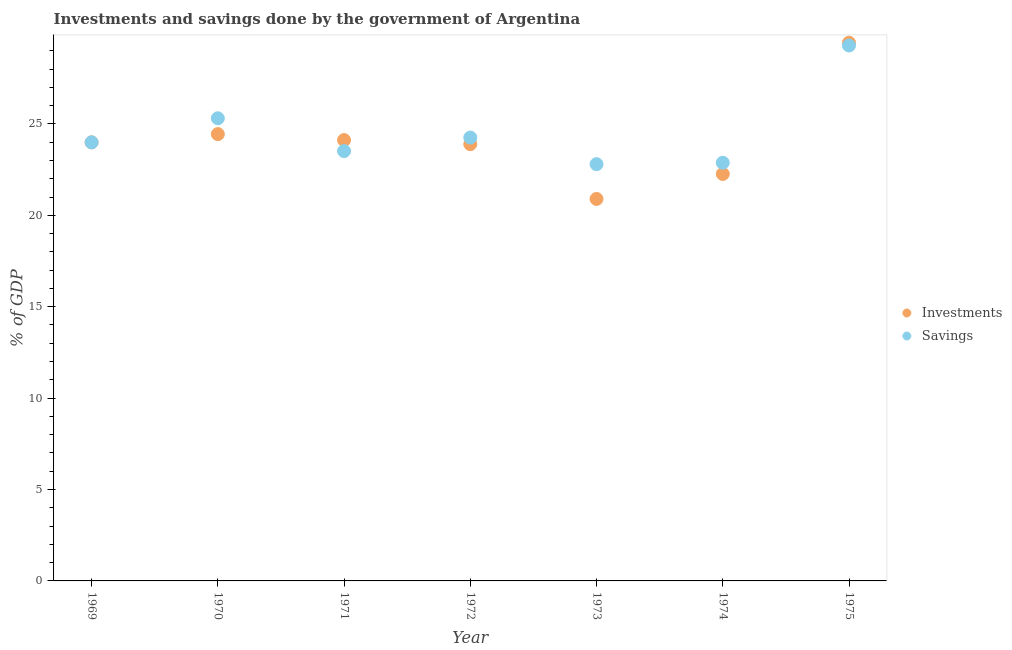What is the investments of government in 1975?
Your answer should be very brief. 29.44. Across all years, what is the maximum investments of government?
Make the answer very short. 29.44. Across all years, what is the minimum savings of government?
Your response must be concise. 22.8. In which year was the investments of government maximum?
Provide a short and direct response. 1975. In which year was the investments of government minimum?
Your answer should be very brief. 1973. What is the total investments of government in the graph?
Provide a succinct answer. 169.03. What is the difference between the savings of government in 1969 and that in 1972?
Keep it short and to the point. -0.26. What is the difference between the investments of government in 1969 and the savings of government in 1970?
Make the answer very short. -1.32. What is the average investments of government per year?
Your response must be concise. 24.15. In the year 1971, what is the difference between the investments of government and savings of government?
Your response must be concise. 0.6. In how many years, is the investments of government greater than 21 %?
Make the answer very short. 6. What is the ratio of the investments of government in 1974 to that in 1975?
Your answer should be very brief. 0.76. Is the investments of government in 1969 less than that in 1974?
Offer a very short reply. No. What is the difference between the highest and the second highest savings of government?
Offer a terse response. 3.98. What is the difference between the highest and the lowest savings of government?
Offer a terse response. 6.49. In how many years, is the investments of government greater than the average investments of government taken over all years?
Your answer should be very brief. 2. Is the sum of the savings of government in 1969 and 1975 greater than the maximum investments of government across all years?
Ensure brevity in your answer.  Yes. Is the savings of government strictly greater than the investments of government over the years?
Your response must be concise. No. How many dotlines are there?
Keep it short and to the point. 2. How many years are there in the graph?
Your answer should be compact. 7. What is the difference between two consecutive major ticks on the Y-axis?
Give a very brief answer. 5. Does the graph contain grids?
Keep it short and to the point. No. How are the legend labels stacked?
Provide a short and direct response. Vertical. What is the title of the graph?
Provide a succinct answer. Investments and savings done by the government of Argentina. Does "Largest city" appear as one of the legend labels in the graph?
Keep it short and to the point. No. What is the label or title of the X-axis?
Offer a very short reply. Year. What is the label or title of the Y-axis?
Provide a short and direct response. % of GDP. What is the % of GDP of Investments in 1969?
Make the answer very short. 23.99. What is the % of GDP in Savings in 1969?
Your answer should be compact. 23.99. What is the % of GDP of Investments in 1970?
Provide a succinct answer. 24.44. What is the % of GDP in Savings in 1970?
Keep it short and to the point. 25.31. What is the % of GDP in Investments in 1971?
Keep it short and to the point. 24.11. What is the % of GDP in Savings in 1971?
Keep it short and to the point. 23.51. What is the % of GDP of Investments in 1972?
Make the answer very short. 23.89. What is the % of GDP of Savings in 1972?
Offer a very short reply. 24.25. What is the % of GDP in Investments in 1973?
Offer a very short reply. 20.89. What is the % of GDP in Savings in 1973?
Give a very brief answer. 22.8. What is the % of GDP in Investments in 1974?
Offer a very short reply. 22.26. What is the % of GDP of Savings in 1974?
Your answer should be very brief. 22.87. What is the % of GDP of Investments in 1975?
Your answer should be very brief. 29.44. What is the % of GDP of Savings in 1975?
Provide a succinct answer. 29.29. Across all years, what is the maximum % of GDP in Investments?
Your answer should be very brief. 29.44. Across all years, what is the maximum % of GDP of Savings?
Offer a very short reply. 29.29. Across all years, what is the minimum % of GDP in Investments?
Provide a short and direct response. 20.89. Across all years, what is the minimum % of GDP of Savings?
Give a very brief answer. 22.8. What is the total % of GDP of Investments in the graph?
Your answer should be compact. 169.03. What is the total % of GDP of Savings in the graph?
Your answer should be compact. 172.02. What is the difference between the % of GDP of Investments in 1969 and that in 1970?
Your response must be concise. -0.45. What is the difference between the % of GDP of Savings in 1969 and that in 1970?
Keep it short and to the point. -1.32. What is the difference between the % of GDP in Investments in 1969 and that in 1971?
Your answer should be very brief. -0.12. What is the difference between the % of GDP in Savings in 1969 and that in 1971?
Provide a succinct answer. 0.48. What is the difference between the % of GDP of Investments in 1969 and that in 1972?
Keep it short and to the point. 0.1. What is the difference between the % of GDP of Savings in 1969 and that in 1972?
Make the answer very short. -0.26. What is the difference between the % of GDP of Investments in 1969 and that in 1973?
Offer a very short reply. 3.1. What is the difference between the % of GDP in Savings in 1969 and that in 1973?
Your response must be concise. 1.19. What is the difference between the % of GDP in Investments in 1969 and that in 1974?
Your answer should be very brief. 1.73. What is the difference between the % of GDP of Savings in 1969 and that in 1974?
Provide a short and direct response. 1.12. What is the difference between the % of GDP in Investments in 1969 and that in 1975?
Provide a succinct answer. -5.45. What is the difference between the % of GDP in Savings in 1969 and that in 1975?
Give a very brief answer. -5.3. What is the difference between the % of GDP in Investments in 1970 and that in 1971?
Provide a succinct answer. 0.33. What is the difference between the % of GDP of Savings in 1970 and that in 1971?
Offer a very short reply. 1.79. What is the difference between the % of GDP in Investments in 1970 and that in 1972?
Your answer should be very brief. 0.55. What is the difference between the % of GDP of Savings in 1970 and that in 1972?
Make the answer very short. 1.05. What is the difference between the % of GDP of Investments in 1970 and that in 1973?
Provide a short and direct response. 3.55. What is the difference between the % of GDP in Savings in 1970 and that in 1973?
Ensure brevity in your answer.  2.51. What is the difference between the % of GDP of Investments in 1970 and that in 1974?
Make the answer very short. 2.18. What is the difference between the % of GDP of Savings in 1970 and that in 1974?
Offer a terse response. 2.43. What is the difference between the % of GDP in Investments in 1970 and that in 1975?
Your answer should be very brief. -5. What is the difference between the % of GDP in Savings in 1970 and that in 1975?
Provide a short and direct response. -3.98. What is the difference between the % of GDP of Investments in 1971 and that in 1972?
Offer a terse response. 0.22. What is the difference between the % of GDP in Savings in 1971 and that in 1972?
Your answer should be compact. -0.74. What is the difference between the % of GDP in Investments in 1971 and that in 1973?
Ensure brevity in your answer.  3.22. What is the difference between the % of GDP of Savings in 1971 and that in 1973?
Provide a short and direct response. 0.72. What is the difference between the % of GDP of Investments in 1971 and that in 1974?
Provide a short and direct response. 1.85. What is the difference between the % of GDP in Savings in 1971 and that in 1974?
Ensure brevity in your answer.  0.64. What is the difference between the % of GDP of Investments in 1971 and that in 1975?
Offer a terse response. -5.33. What is the difference between the % of GDP of Savings in 1971 and that in 1975?
Offer a terse response. -5.77. What is the difference between the % of GDP in Investments in 1972 and that in 1973?
Offer a very short reply. 3. What is the difference between the % of GDP in Savings in 1972 and that in 1973?
Keep it short and to the point. 1.45. What is the difference between the % of GDP in Investments in 1972 and that in 1974?
Your answer should be very brief. 1.63. What is the difference between the % of GDP of Savings in 1972 and that in 1974?
Keep it short and to the point. 1.38. What is the difference between the % of GDP in Investments in 1972 and that in 1975?
Offer a terse response. -5.55. What is the difference between the % of GDP of Savings in 1972 and that in 1975?
Provide a succinct answer. -5.04. What is the difference between the % of GDP of Investments in 1973 and that in 1974?
Your answer should be compact. -1.37. What is the difference between the % of GDP in Savings in 1973 and that in 1974?
Your answer should be compact. -0.08. What is the difference between the % of GDP of Investments in 1973 and that in 1975?
Your response must be concise. -8.55. What is the difference between the % of GDP of Savings in 1973 and that in 1975?
Your answer should be very brief. -6.49. What is the difference between the % of GDP of Investments in 1974 and that in 1975?
Provide a short and direct response. -7.18. What is the difference between the % of GDP of Savings in 1974 and that in 1975?
Offer a very short reply. -6.41. What is the difference between the % of GDP of Investments in 1969 and the % of GDP of Savings in 1970?
Offer a terse response. -1.32. What is the difference between the % of GDP of Investments in 1969 and the % of GDP of Savings in 1971?
Make the answer very short. 0.48. What is the difference between the % of GDP of Investments in 1969 and the % of GDP of Savings in 1972?
Keep it short and to the point. -0.26. What is the difference between the % of GDP of Investments in 1969 and the % of GDP of Savings in 1973?
Your answer should be very brief. 1.19. What is the difference between the % of GDP of Investments in 1969 and the % of GDP of Savings in 1974?
Provide a succinct answer. 1.12. What is the difference between the % of GDP of Investments in 1969 and the % of GDP of Savings in 1975?
Offer a very short reply. -5.3. What is the difference between the % of GDP in Investments in 1970 and the % of GDP in Savings in 1971?
Make the answer very short. 0.93. What is the difference between the % of GDP in Investments in 1970 and the % of GDP in Savings in 1972?
Ensure brevity in your answer.  0.19. What is the difference between the % of GDP of Investments in 1970 and the % of GDP of Savings in 1973?
Offer a very short reply. 1.64. What is the difference between the % of GDP of Investments in 1970 and the % of GDP of Savings in 1974?
Give a very brief answer. 1.57. What is the difference between the % of GDP in Investments in 1970 and the % of GDP in Savings in 1975?
Provide a short and direct response. -4.85. What is the difference between the % of GDP of Investments in 1971 and the % of GDP of Savings in 1972?
Your response must be concise. -0.14. What is the difference between the % of GDP in Investments in 1971 and the % of GDP in Savings in 1973?
Provide a short and direct response. 1.32. What is the difference between the % of GDP of Investments in 1971 and the % of GDP of Savings in 1974?
Provide a succinct answer. 1.24. What is the difference between the % of GDP of Investments in 1971 and the % of GDP of Savings in 1975?
Keep it short and to the point. -5.17. What is the difference between the % of GDP of Investments in 1972 and the % of GDP of Savings in 1973?
Provide a short and direct response. 1.09. What is the difference between the % of GDP in Investments in 1972 and the % of GDP in Savings in 1974?
Give a very brief answer. 1.02. What is the difference between the % of GDP of Investments in 1972 and the % of GDP of Savings in 1975?
Provide a succinct answer. -5.39. What is the difference between the % of GDP of Investments in 1973 and the % of GDP of Savings in 1974?
Keep it short and to the point. -1.98. What is the difference between the % of GDP of Investments in 1973 and the % of GDP of Savings in 1975?
Provide a succinct answer. -8.39. What is the difference between the % of GDP in Investments in 1974 and the % of GDP in Savings in 1975?
Make the answer very short. -7.03. What is the average % of GDP in Investments per year?
Offer a very short reply. 24.15. What is the average % of GDP in Savings per year?
Offer a very short reply. 24.57. In the year 1969, what is the difference between the % of GDP of Investments and % of GDP of Savings?
Give a very brief answer. 0. In the year 1970, what is the difference between the % of GDP of Investments and % of GDP of Savings?
Offer a very short reply. -0.87. In the year 1971, what is the difference between the % of GDP of Investments and % of GDP of Savings?
Offer a very short reply. 0.6. In the year 1972, what is the difference between the % of GDP of Investments and % of GDP of Savings?
Your response must be concise. -0.36. In the year 1973, what is the difference between the % of GDP in Investments and % of GDP in Savings?
Ensure brevity in your answer.  -1.9. In the year 1974, what is the difference between the % of GDP of Investments and % of GDP of Savings?
Your response must be concise. -0.61. In the year 1975, what is the difference between the % of GDP in Investments and % of GDP in Savings?
Give a very brief answer. 0.15. What is the ratio of the % of GDP of Investments in 1969 to that in 1970?
Your answer should be compact. 0.98. What is the ratio of the % of GDP in Savings in 1969 to that in 1970?
Offer a terse response. 0.95. What is the ratio of the % of GDP of Savings in 1969 to that in 1971?
Offer a terse response. 1.02. What is the ratio of the % of GDP of Investments in 1969 to that in 1972?
Give a very brief answer. 1. What is the ratio of the % of GDP in Savings in 1969 to that in 1972?
Keep it short and to the point. 0.99. What is the ratio of the % of GDP of Investments in 1969 to that in 1973?
Provide a succinct answer. 1.15. What is the ratio of the % of GDP of Savings in 1969 to that in 1973?
Make the answer very short. 1.05. What is the ratio of the % of GDP of Investments in 1969 to that in 1974?
Your answer should be compact. 1.08. What is the ratio of the % of GDP in Savings in 1969 to that in 1974?
Ensure brevity in your answer.  1.05. What is the ratio of the % of GDP in Investments in 1969 to that in 1975?
Give a very brief answer. 0.81. What is the ratio of the % of GDP of Savings in 1969 to that in 1975?
Ensure brevity in your answer.  0.82. What is the ratio of the % of GDP in Investments in 1970 to that in 1971?
Your answer should be compact. 1.01. What is the ratio of the % of GDP of Savings in 1970 to that in 1971?
Offer a very short reply. 1.08. What is the ratio of the % of GDP of Savings in 1970 to that in 1972?
Your response must be concise. 1.04. What is the ratio of the % of GDP of Investments in 1970 to that in 1973?
Provide a succinct answer. 1.17. What is the ratio of the % of GDP in Savings in 1970 to that in 1973?
Give a very brief answer. 1.11. What is the ratio of the % of GDP in Investments in 1970 to that in 1974?
Give a very brief answer. 1.1. What is the ratio of the % of GDP of Savings in 1970 to that in 1974?
Make the answer very short. 1.11. What is the ratio of the % of GDP of Investments in 1970 to that in 1975?
Make the answer very short. 0.83. What is the ratio of the % of GDP in Savings in 1970 to that in 1975?
Ensure brevity in your answer.  0.86. What is the ratio of the % of GDP of Investments in 1971 to that in 1972?
Give a very brief answer. 1.01. What is the ratio of the % of GDP in Savings in 1971 to that in 1972?
Your answer should be very brief. 0.97. What is the ratio of the % of GDP of Investments in 1971 to that in 1973?
Your answer should be compact. 1.15. What is the ratio of the % of GDP in Savings in 1971 to that in 1973?
Make the answer very short. 1.03. What is the ratio of the % of GDP in Investments in 1971 to that in 1974?
Keep it short and to the point. 1.08. What is the ratio of the % of GDP of Savings in 1971 to that in 1974?
Your answer should be very brief. 1.03. What is the ratio of the % of GDP of Investments in 1971 to that in 1975?
Your answer should be compact. 0.82. What is the ratio of the % of GDP of Savings in 1971 to that in 1975?
Offer a terse response. 0.8. What is the ratio of the % of GDP of Investments in 1972 to that in 1973?
Your answer should be very brief. 1.14. What is the ratio of the % of GDP of Savings in 1972 to that in 1973?
Your answer should be compact. 1.06. What is the ratio of the % of GDP in Investments in 1972 to that in 1974?
Provide a succinct answer. 1.07. What is the ratio of the % of GDP in Savings in 1972 to that in 1974?
Make the answer very short. 1.06. What is the ratio of the % of GDP in Investments in 1972 to that in 1975?
Keep it short and to the point. 0.81. What is the ratio of the % of GDP in Savings in 1972 to that in 1975?
Provide a succinct answer. 0.83. What is the ratio of the % of GDP in Investments in 1973 to that in 1974?
Keep it short and to the point. 0.94. What is the ratio of the % of GDP in Investments in 1973 to that in 1975?
Make the answer very short. 0.71. What is the ratio of the % of GDP of Savings in 1973 to that in 1975?
Your answer should be very brief. 0.78. What is the ratio of the % of GDP in Investments in 1974 to that in 1975?
Provide a succinct answer. 0.76. What is the ratio of the % of GDP in Savings in 1974 to that in 1975?
Provide a short and direct response. 0.78. What is the difference between the highest and the second highest % of GDP of Investments?
Your answer should be very brief. 5. What is the difference between the highest and the second highest % of GDP of Savings?
Your answer should be very brief. 3.98. What is the difference between the highest and the lowest % of GDP of Investments?
Offer a terse response. 8.55. What is the difference between the highest and the lowest % of GDP in Savings?
Keep it short and to the point. 6.49. 